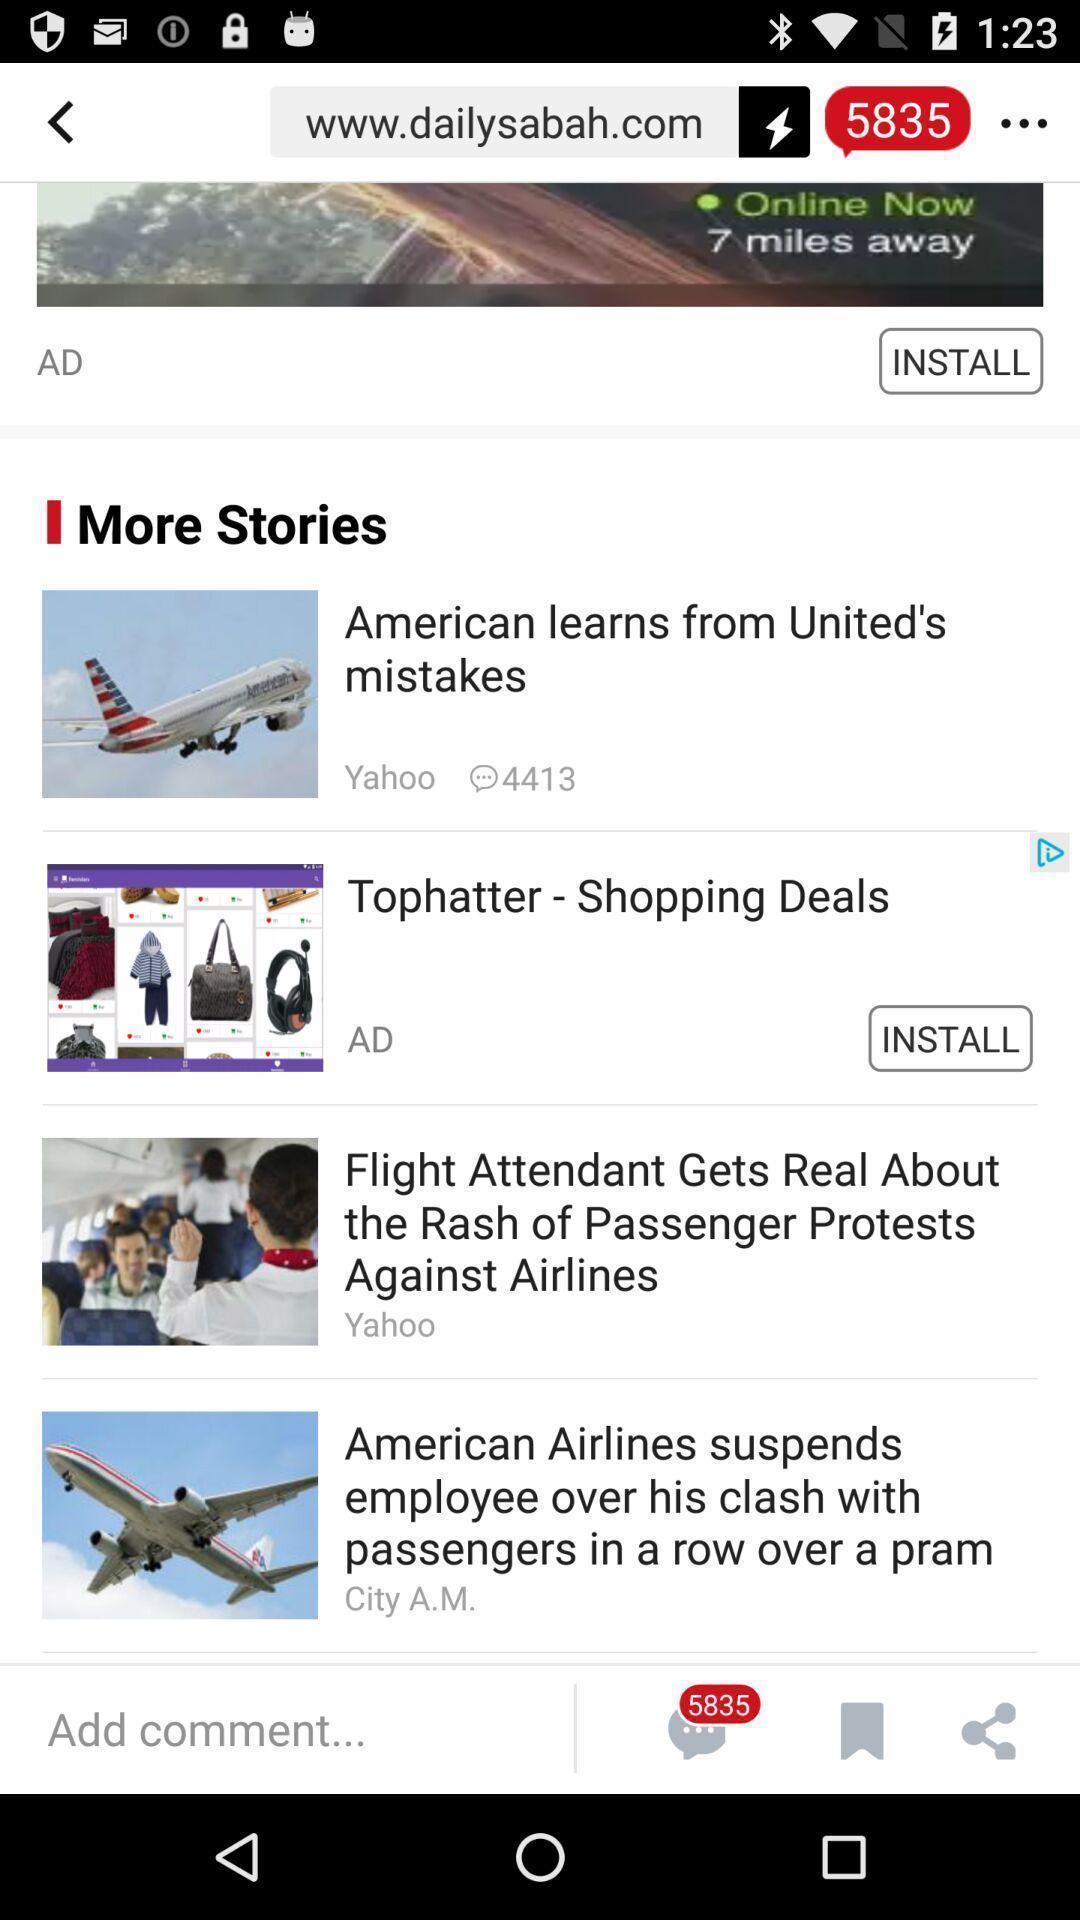Provide a detailed account of this screenshot. Screen shows more stories in a news app. 